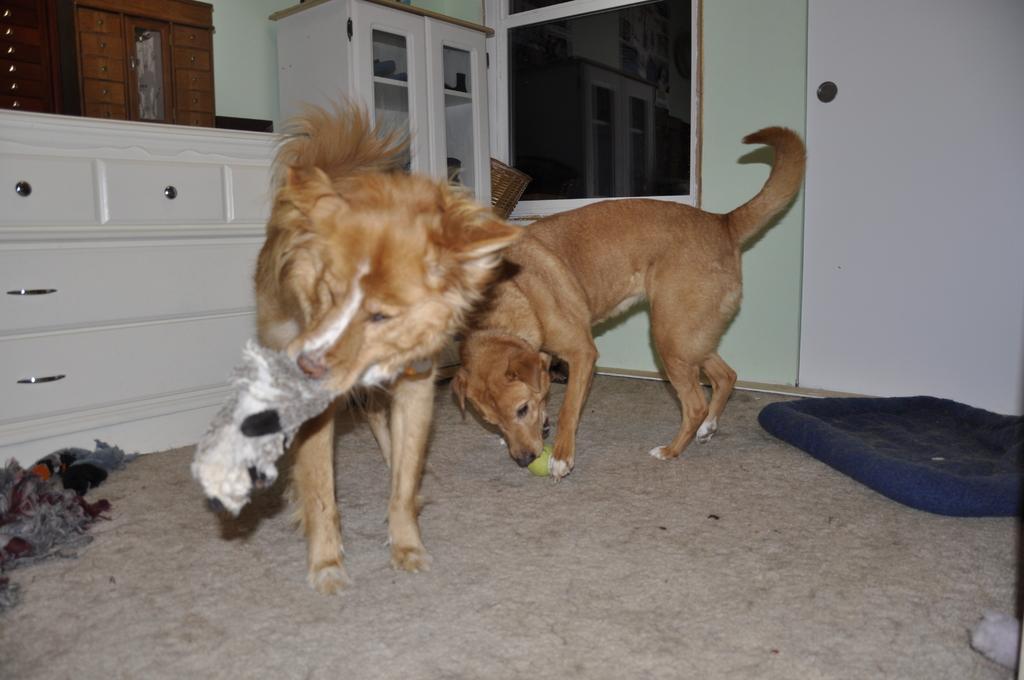How would you summarize this image in a sentence or two? In this image we can see two dogs. One dog is holding grey color thing in mouth and other dog is playing with ball. Behind them cupboards, window, wall and door are present. Right side of the image some dark blue color thing is present on the floor. Left side of the image cloth is there. 